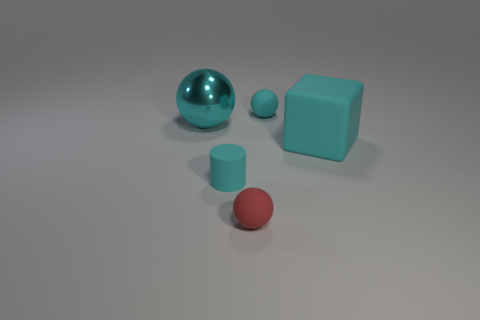Add 3 matte objects. How many objects exist? 8 Subtract all large cyan spheres. How many spheres are left? 2 Subtract all gray balls. Subtract all yellow cubes. How many balls are left? 3 Subtract all cylinders. How many objects are left? 4 Add 4 cyan matte spheres. How many cyan matte spheres exist? 5 Subtract 0 gray balls. How many objects are left? 5 Subtract all cyan matte spheres. Subtract all cyan rubber cubes. How many objects are left? 3 Add 4 cyan rubber things. How many cyan rubber things are left? 7 